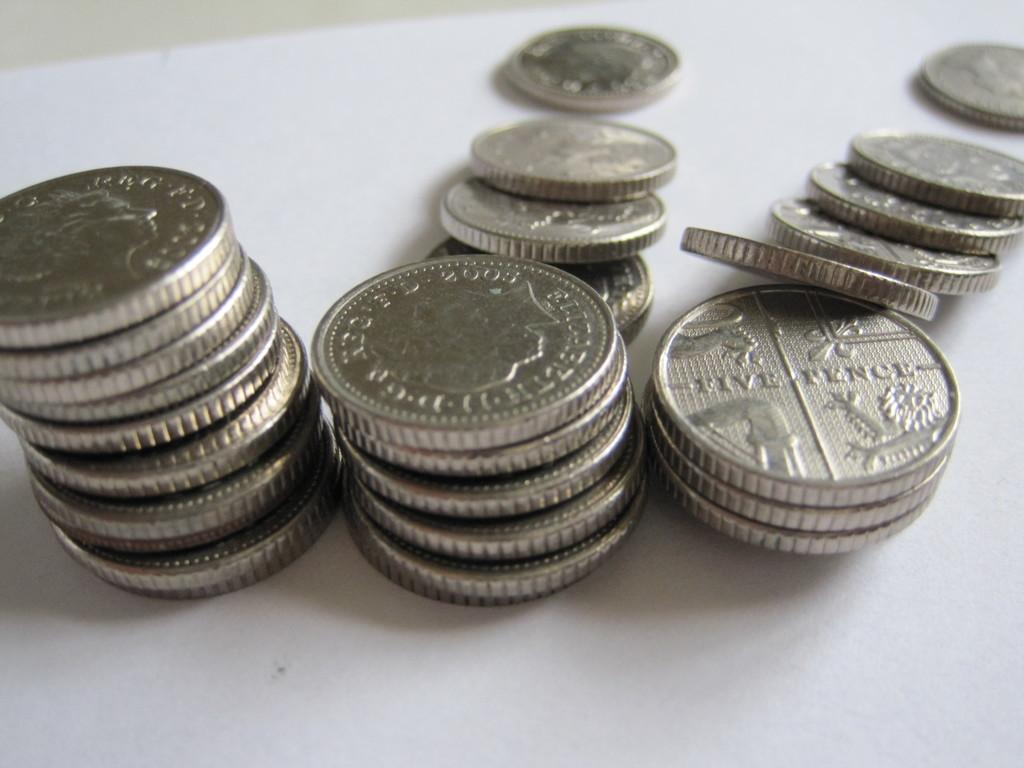<image>
Describe the image concisely. several five pence coins arestacked on top of each other while some have fallen off. 